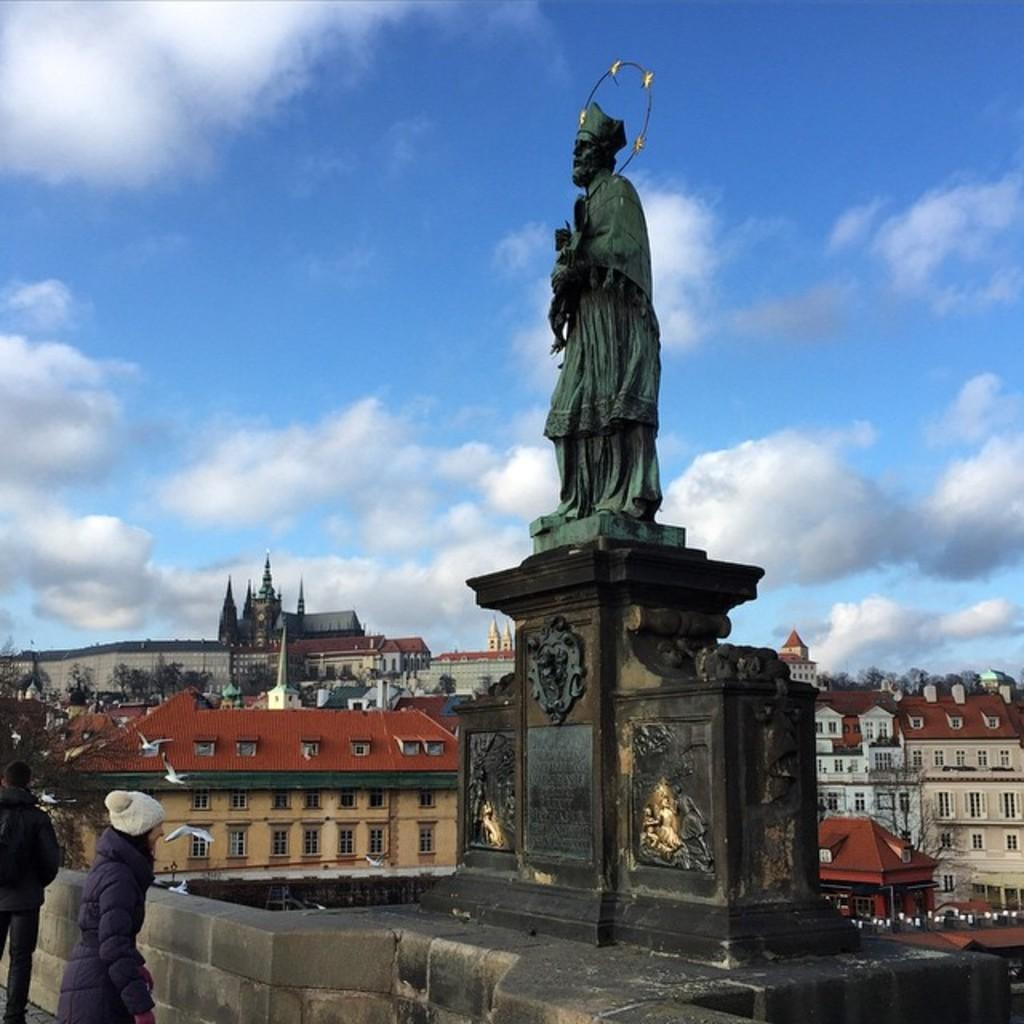What type of structures can be seen in the image? There are buildings in the image. What is the statue in the image depicting? The statue in the image is not specified, so we cannot determine what it is depicting. What is the memorial stone in the image for? The purpose of the memorial stone in the image is not specified, so we cannot determine what it is for. How would you describe the weather in the image? The sky is cloudy in the image, suggesting a potentially overcast or cloudy day. Can you describe the people in the image? There are people in the image, but their specific actions or appearances are not specified. What type of vegetation is present in the image? There are trees in the image, indicating the presence of some natural vegetation. What type of animals can be seen in the image? There are birds in the image, but no other animals are mentioned. What other unspecified objects are present in the image? There are unspecified objects in the image, but their nature or purpose is not mentioned. What type of sugar is being used to sweeten the porter in the image? There is no mention of sugar or porter in the image, so we cannot determine if any sugar is being used to sweeten a porter. What advice is being given to the person in the image? There is no indication of any advice being given in the image, so we cannot determine what advice might be given. 